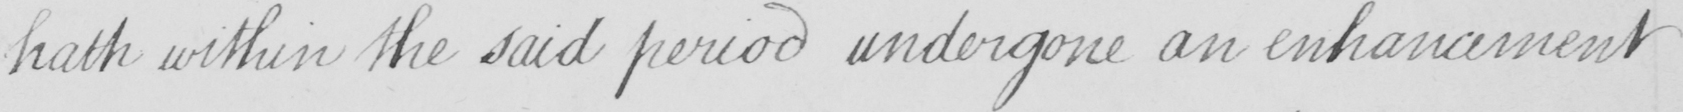Please transcribe the handwritten text in this image. hath within the said period undergone an enhancement 